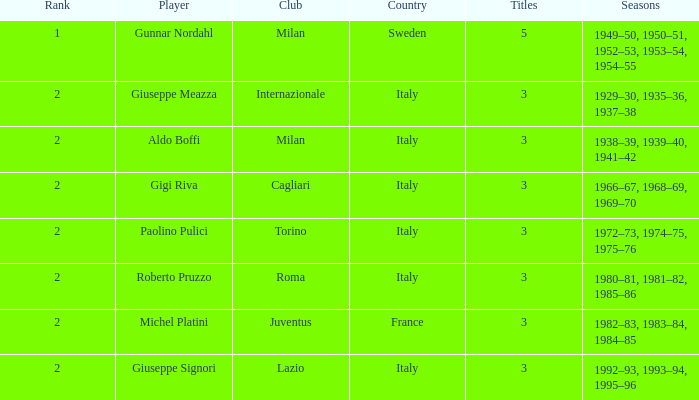How many rankings are associated with giuseppe meazza holding over 3 titles? 0.0. 